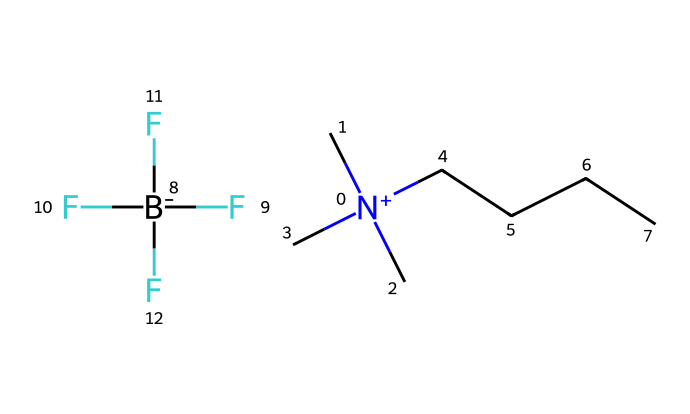How many carbon atoms are in this ionic liquid? Analyzing the SMILES representation, we see "C" appears multiple times for carbon atoms. The molecular structure features three "C" from the trimethylammonium portion [N+](C)(C)(C) and five from the pentyl chain "CCCC." Therefore, we count 3 + 5 = 8 carbon atoms.
Answer: 8 What is the charge of the cation in this ionic liquid? The cation section of the SMILES includes [N+], indicating that the nitrogen atom carries a positive charge. This is characteristic of higher alkyl ammonium cations, which are often used in ionic liquids.
Answer: positive How many fluorine atoms are present in the anion? The anion part of the structure is represented by [B-](F)(F)(F)F, which shows that there are four fluorine atoms bonded to the boron atom and that the boron carries a negative charge. By counting the "F" in the SMILES representation, we determine there are four fluorine atoms.
Answer: 4 What type of bonding is likely present between the cation and anion? Given that this is an ionic liquid, the bonding between the cation (the positively charged nitrogen compound) and the anion (the negatively charged tetrafluoroborate) is ionic in nature. Ionic bonds occur due to the electrostatic attraction between positively and negatively charged ions.
Answer: ionic What functional group does the nitrogen atom represent in this ionic liquid? The nitrogen atom in this chemical is part of the quaternary ammonium structure, as indicated by its positive charge and being bonded to four substituents (three methyl groups and one pentyl chain). Quaternary ammonium compounds are a specific subclass of amines with a nitrogen atom bonded to four organic groups.
Answer: quaternary ammonium What is the role of ionic liquids like this one in corrosion-resistant coatings? Ionic liquids are typically non-volatile and can provide a stable, protective barrier. They can reduce the electrochemical reactions that cause corrosion on metal surfaces, thus enhancing the durability of coatings when applied to household appliances. Their unique properties, including high thermal stability and ionic conductivity, make them suitable for such applications.
Answer: corrosion resistance 